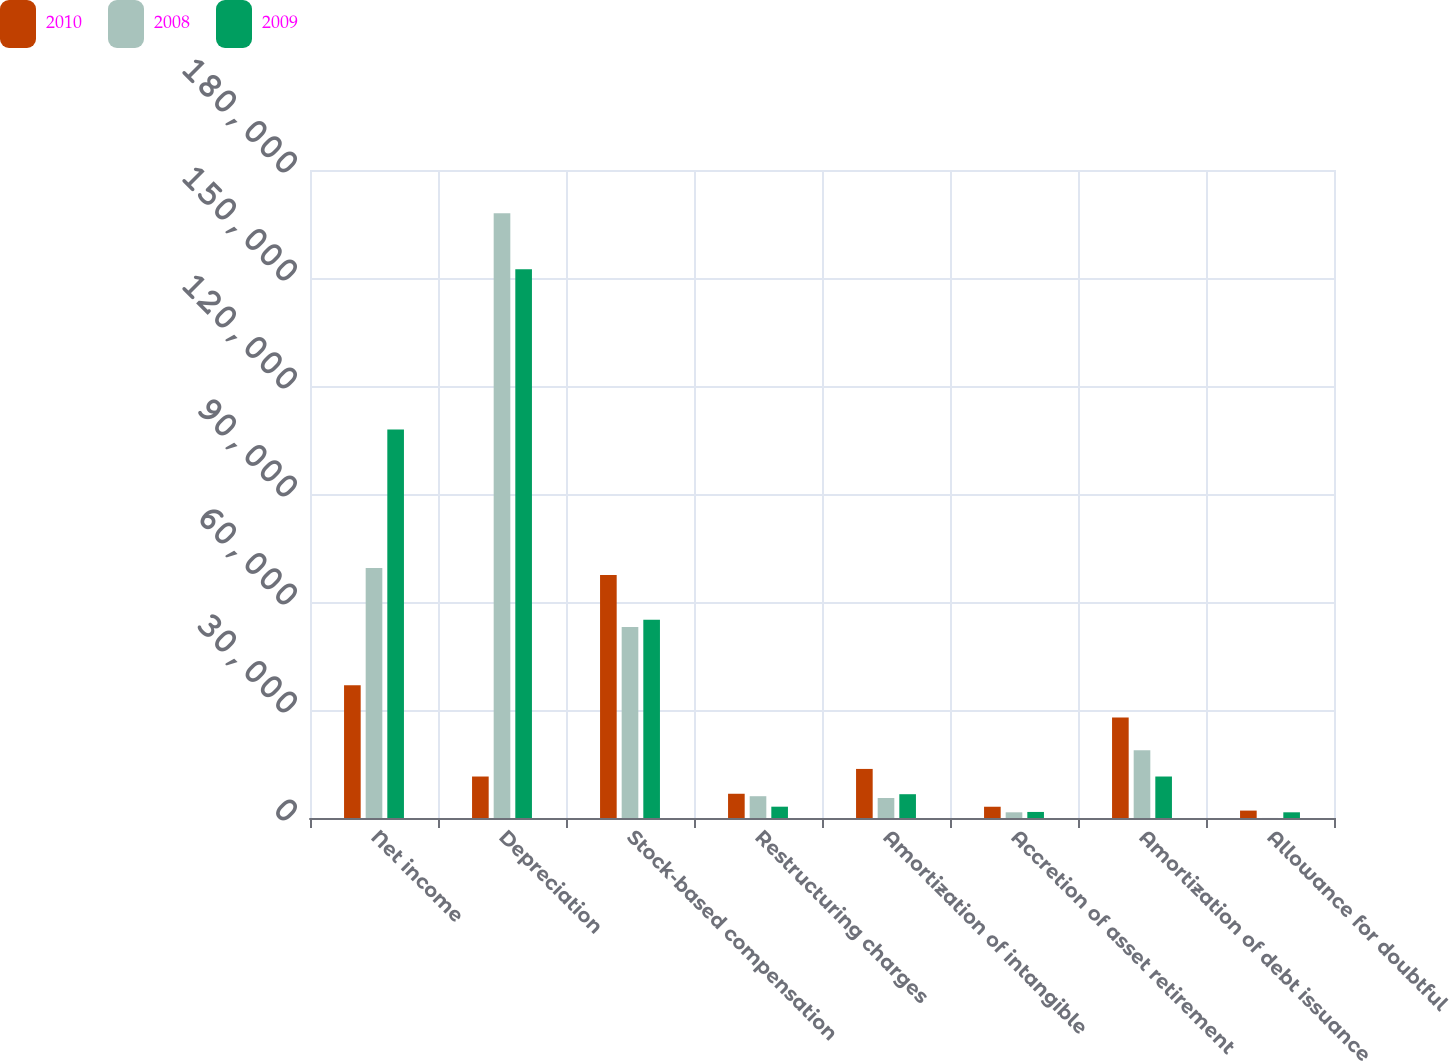Convert chart. <chart><loc_0><loc_0><loc_500><loc_500><stacked_bar_chart><ecel><fcel>Net income<fcel>Depreciation<fcel>Stock-based compensation<fcel>Restructuring charges<fcel>Amortization of intangible<fcel>Accretion of asset retirement<fcel>Amortization of debt issuance<fcel>Allowance for doubtful<nl><fcel>2010<fcel>36881<fcel>11523<fcel>67489<fcel>6734<fcel>13632<fcel>3128<fcel>27915<fcel>2056<nl><fcel>2008<fcel>69431<fcel>167975<fcel>53056<fcel>6053<fcel>5555<fcel>1581<fcel>18791<fcel>15<nl><fcel>2009<fcel>107924<fcel>152437<fcel>55085<fcel>3142<fcel>6610<fcel>1682<fcel>11523<fcel>1582<nl></chart> 